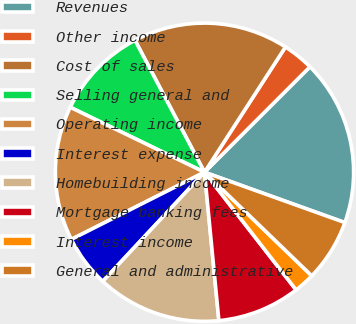Convert chart to OTSL. <chart><loc_0><loc_0><loc_500><loc_500><pie_chart><fcel>Revenues<fcel>Other income<fcel>Cost of sales<fcel>Selling general and<fcel>Operating income<fcel>Interest expense<fcel>Homebuilding income<fcel>Mortgage banking fees<fcel>Interest income<fcel>General and administrative<nl><fcel>17.98%<fcel>3.37%<fcel>16.85%<fcel>10.11%<fcel>14.61%<fcel>5.62%<fcel>13.48%<fcel>8.99%<fcel>2.25%<fcel>6.74%<nl></chart> 